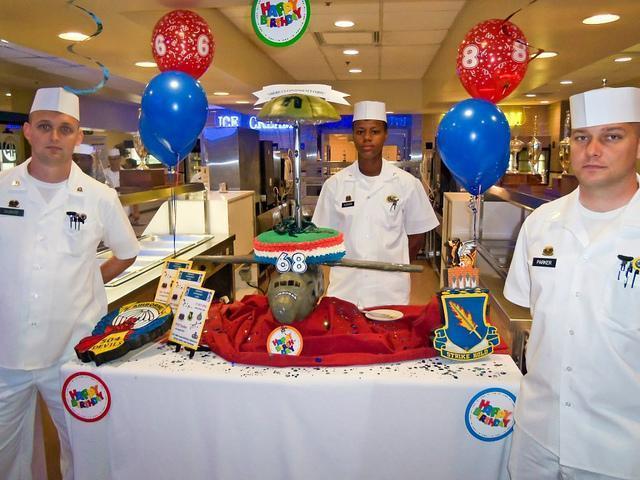Verify the accuracy of this image caption: "The airplane is on the dining table.".
Answer yes or no. Yes. Is "The umbrella is over the dining table." an appropriate description for the image?
Answer yes or no. Yes. 